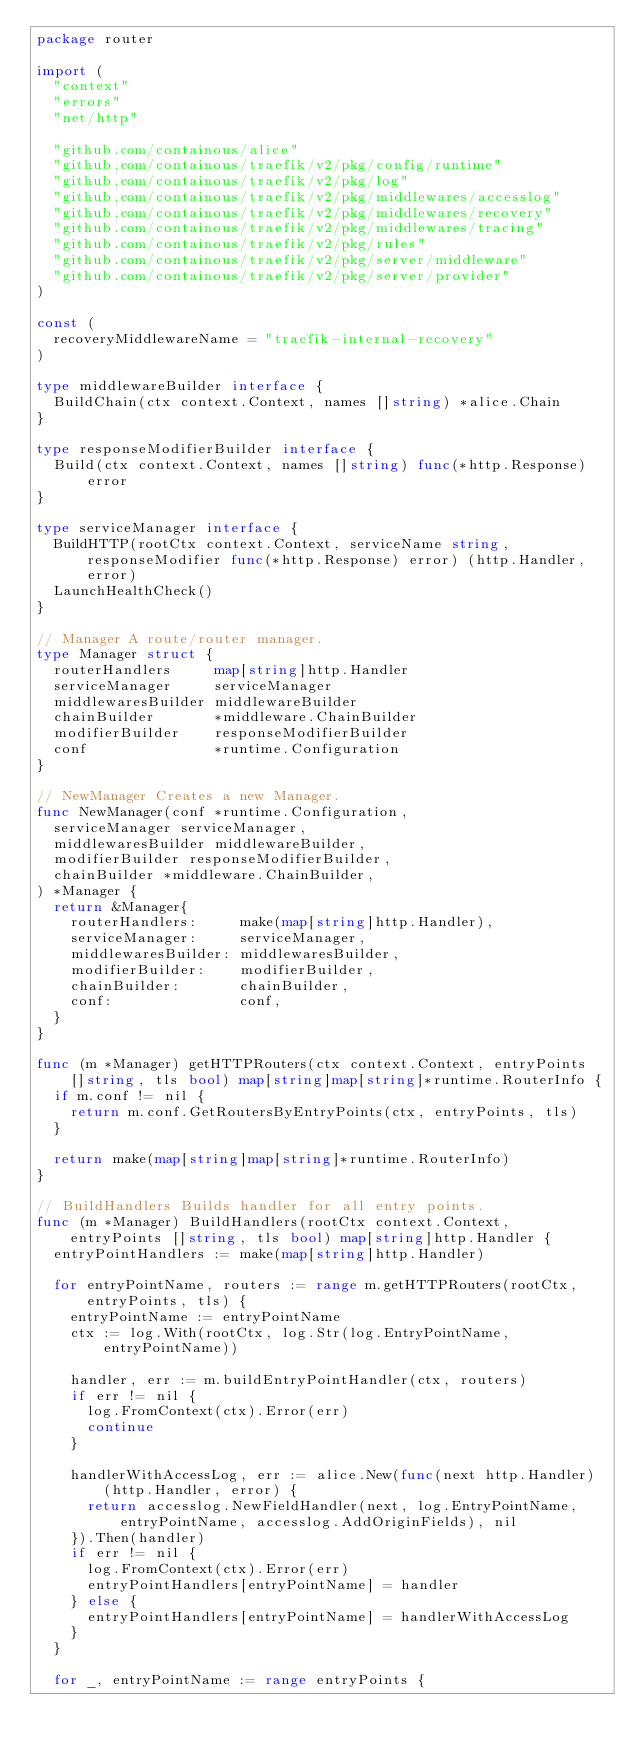Convert code to text. <code><loc_0><loc_0><loc_500><loc_500><_Go_>package router

import (
	"context"
	"errors"
	"net/http"

	"github.com/containous/alice"
	"github.com/containous/traefik/v2/pkg/config/runtime"
	"github.com/containous/traefik/v2/pkg/log"
	"github.com/containous/traefik/v2/pkg/middlewares/accesslog"
	"github.com/containous/traefik/v2/pkg/middlewares/recovery"
	"github.com/containous/traefik/v2/pkg/middlewares/tracing"
	"github.com/containous/traefik/v2/pkg/rules"
	"github.com/containous/traefik/v2/pkg/server/middleware"
	"github.com/containous/traefik/v2/pkg/server/provider"
)

const (
	recoveryMiddlewareName = "traefik-internal-recovery"
)

type middlewareBuilder interface {
	BuildChain(ctx context.Context, names []string) *alice.Chain
}

type responseModifierBuilder interface {
	Build(ctx context.Context, names []string) func(*http.Response) error
}

type serviceManager interface {
	BuildHTTP(rootCtx context.Context, serviceName string, responseModifier func(*http.Response) error) (http.Handler, error)
	LaunchHealthCheck()
}

// Manager A route/router manager.
type Manager struct {
	routerHandlers     map[string]http.Handler
	serviceManager     serviceManager
	middlewaresBuilder middlewareBuilder
	chainBuilder       *middleware.ChainBuilder
	modifierBuilder    responseModifierBuilder
	conf               *runtime.Configuration
}

// NewManager Creates a new Manager.
func NewManager(conf *runtime.Configuration,
	serviceManager serviceManager,
	middlewaresBuilder middlewareBuilder,
	modifierBuilder responseModifierBuilder,
	chainBuilder *middleware.ChainBuilder,
) *Manager {
	return &Manager{
		routerHandlers:     make(map[string]http.Handler),
		serviceManager:     serviceManager,
		middlewaresBuilder: middlewaresBuilder,
		modifierBuilder:    modifierBuilder,
		chainBuilder:       chainBuilder,
		conf:               conf,
	}
}

func (m *Manager) getHTTPRouters(ctx context.Context, entryPoints []string, tls bool) map[string]map[string]*runtime.RouterInfo {
	if m.conf != nil {
		return m.conf.GetRoutersByEntryPoints(ctx, entryPoints, tls)
	}

	return make(map[string]map[string]*runtime.RouterInfo)
}

// BuildHandlers Builds handler for all entry points.
func (m *Manager) BuildHandlers(rootCtx context.Context, entryPoints []string, tls bool) map[string]http.Handler {
	entryPointHandlers := make(map[string]http.Handler)

	for entryPointName, routers := range m.getHTTPRouters(rootCtx, entryPoints, tls) {
		entryPointName := entryPointName
		ctx := log.With(rootCtx, log.Str(log.EntryPointName, entryPointName))

		handler, err := m.buildEntryPointHandler(ctx, routers)
		if err != nil {
			log.FromContext(ctx).Error(err)
			continue
		}

		handlerWithAccessLog, err := alice.New(func(next http.Handler) (http.Handler, error) {
			return accesslog.NewFieldHandler(next, log.EntryPointName, entryPointName, accesslog.AddOriginFields), nil
		}).Then(handler)
		if err != nil {
			log.FromContext(ctx).Error(err)
			entryPointHandlers[entryPointName] = handler
		} else {
			entryPointHandlers[entryPointName] = handlerWithAccessLog
		}
	}

	for _, entryPointName := range entryPoints {</code> 